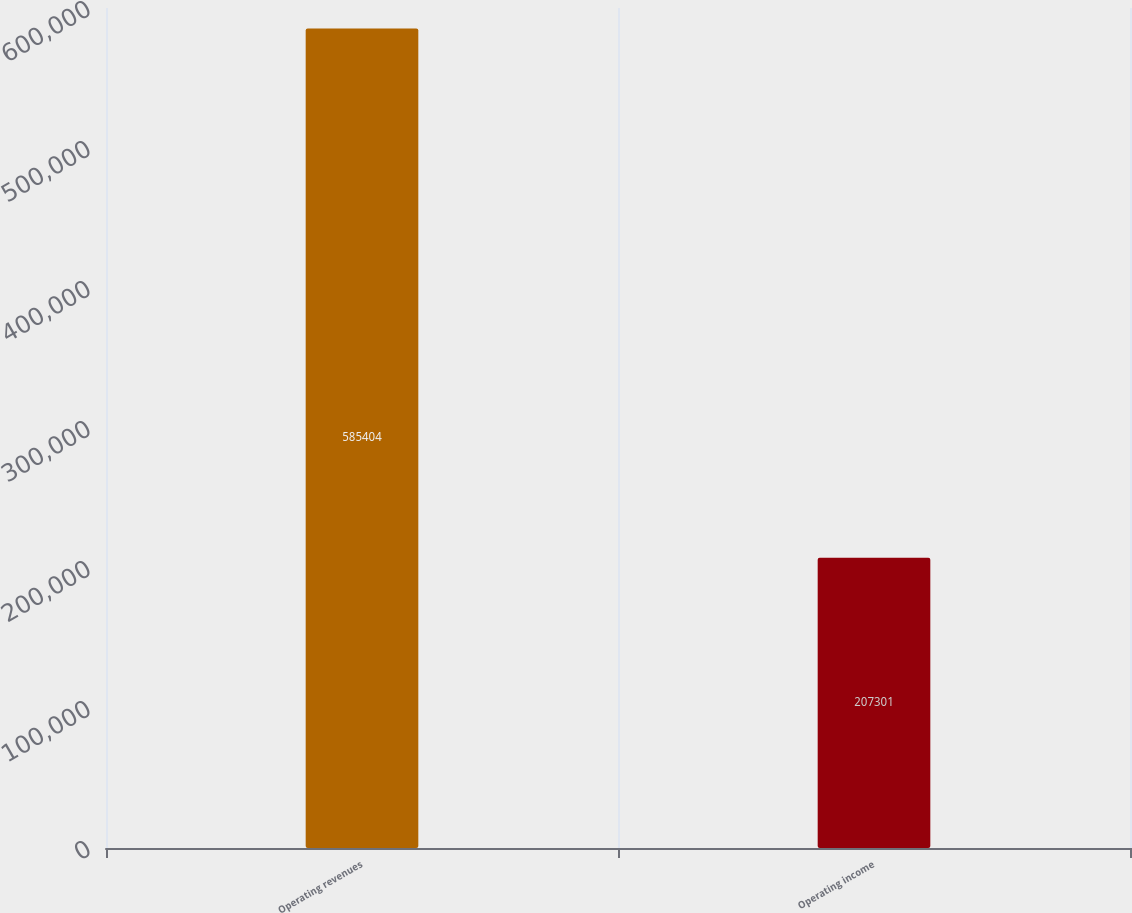Convert chart to OTSL. <chart><loc_0><loc_0><loc_500><loc_500><bar_chart><fcel>Operating revenues<fcel>Operating income<nl><fcel>585404<fcel>207301<nl></chart> 